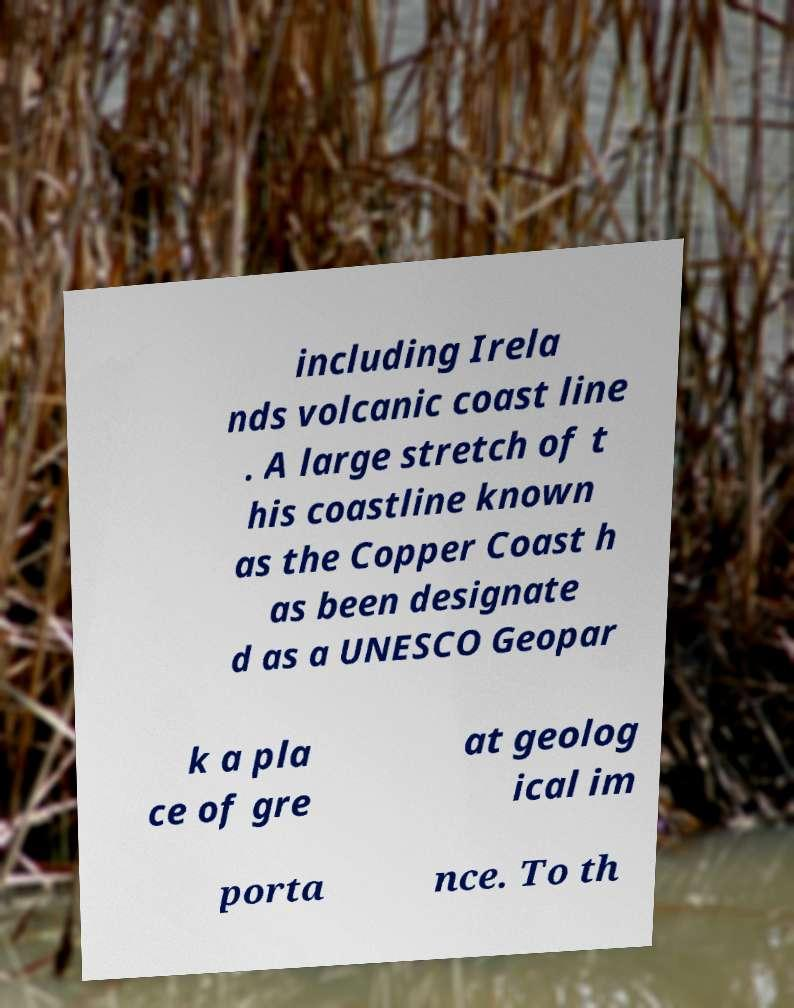Can you accurately transcribe the text from the provided image for me? including Irela nds volcanic coast line . A large stretch of t his coastline known as the Copper Coast h as been designate d as a UNESCO Geopar k a pla ce of gre at geolog ical im porta nce. To th 